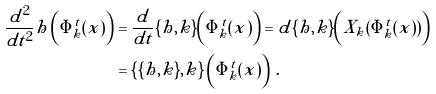<formula> <loc_0><loc_0><loc_500><loc_500>\frac { d ^ { 2 } } { d t ^ { 2 } } h \left ( \Phi _ { k } ^ { t } ( x ) \right ) & = \frac { d } { d t } \{ h , k \} \left ( \Phi _ { k } ^ { t } ( x ) \right ) = d \{ h , k \} \left ( X _ { k } ( \Phi _ { k } ^ { t } ( x ) ) \right ) \\ & = \left \{ \{ h , k \} , k \right \} \left ( \Phi _ { k } ^ { t } ( x ) \right ) \, .</formula> 